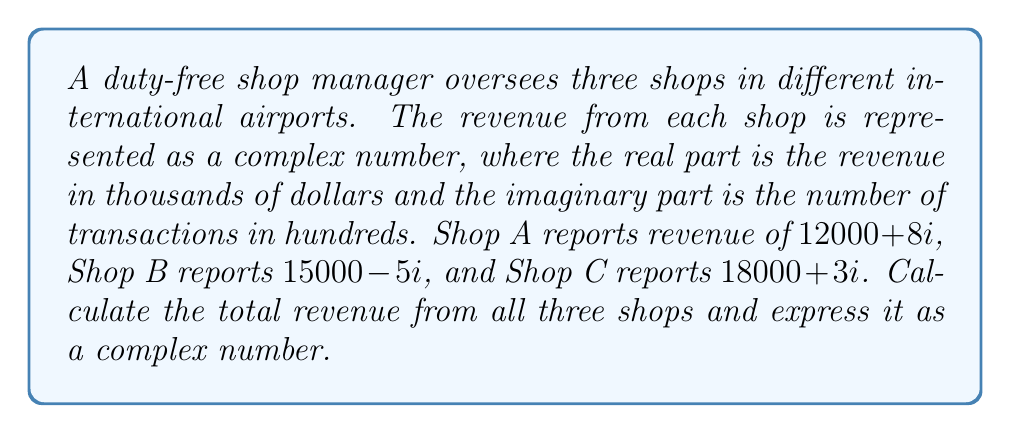Could you help me with this problem? To calculate the total revenue from all three shops, we need to add the complex numbers representing each shop's revenue:

1) Shop A: $12000 + 8i$
2) Shop B: $15000 - 5i$
3) Shop C: $18000 + 3i$

Let's add these complex numbers:

$$(12000 + 8i) + (15000 - 5i) + (18000 + 3i)$$

First, we add the real parts:
$$12000 + 15000 + 18000 = 45000$$

Then, we add the imaginary parts:
$$8i - 5i + 3i = 6i$$

Therefore, the sum of the complex numbers is:

$$45000 + 6i$$

This result means:
- The total revenue from all three shops is $45,000
- The total number of transactions is 600 (6 * 100, as the imaginary part represents hundreds of transactions)
Answer: $45000 + 6i$ 